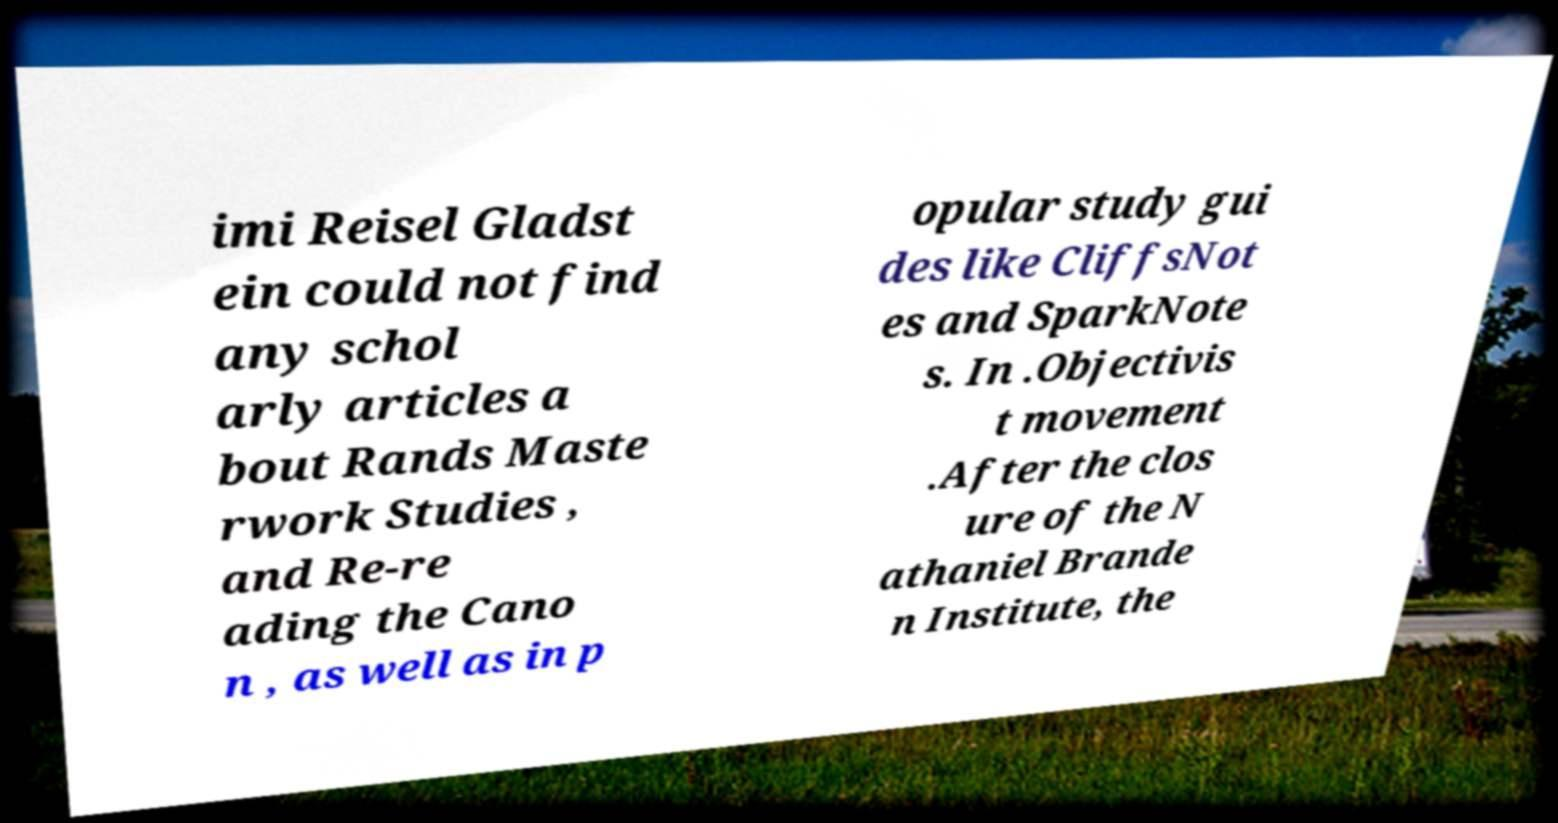Please read and relay the text visible in this image. What does it say? imi Reisel Gladst ein could not find any schol arly articles a bout Rands Maste rwork Studies , and Re-re ading the Cano n , as well as in p opular study gui des like CliffsNot es and SparkNote s. In .Objectivis t movement .After the clos ure of the N athaniel Brande n Institute, the 